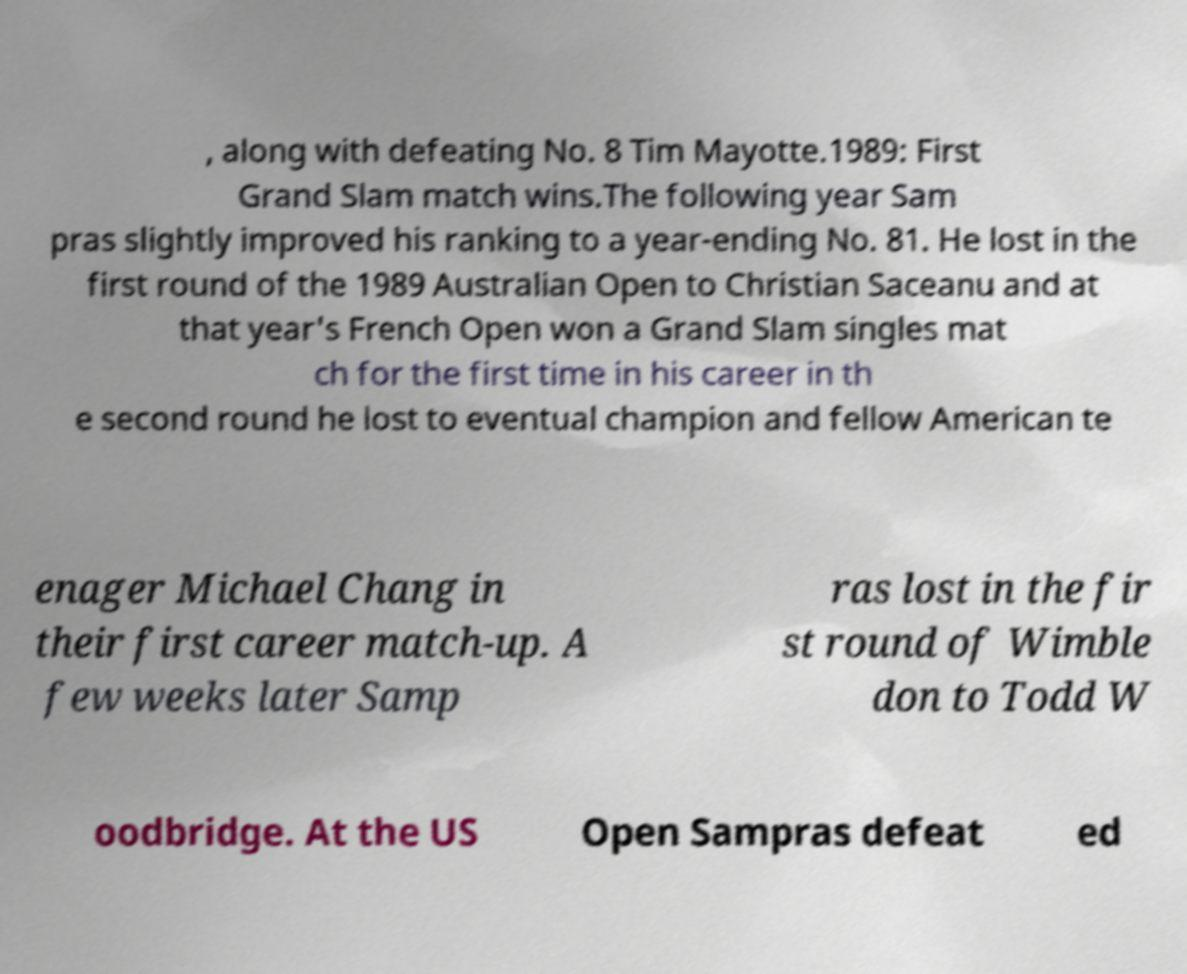I need the written content from this picture converted into text. Can you do that? , along with defeating No. 8 Tim Mayotte.1989: First Grand Slam match wins.The following year Sam pras slightly improved his ranking to a year-ending No. 81. He lost in the first round of the 1989 Australian Open to Christian Saceanu and at that year's French Open won a Grand Slam singles mat ch for the first time in his career in th e second round he lost to eventual champion and fellow American te enager Michael Chang in their first career match-up. A few weeks later Samp ras lost in the fir st round of Wimble don to Todd W oodbridge. At the US Open Sampras defeat ed 